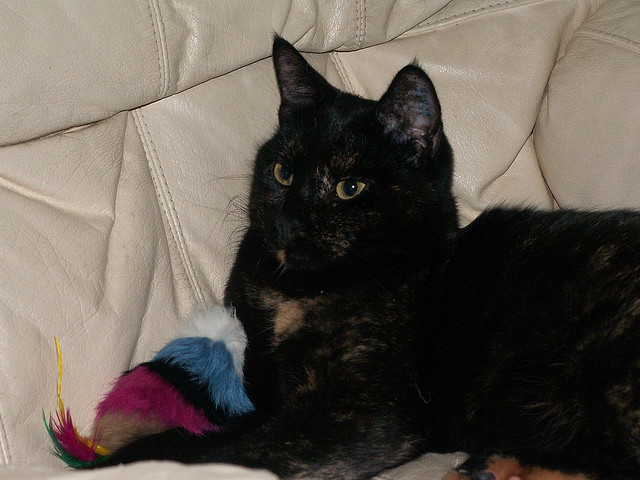<image>What is the cat looking at? The cat appears to be looking at a person, but it's not sure whether it is its owner or something else right in front of it. It is uncertain exactly what the cat is looking at. What is the cat looking at? I am not sure what the cat is looking at. It can be looking at a person, camera, its owner, food, toy, or something right in front of it. 